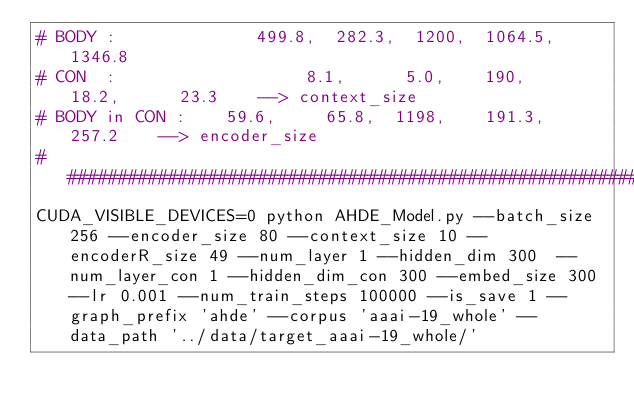<code> <loc_0><loc_0><loc_500><loc_500><_Bash_># BODY :              499.8,  282.3,  1200,  1064.5,  1346.8
# CON  :                   8.1,      5.0,    190,      18.2,      23.3    --> context_size
# BODY in CON :    59.6,     65.8,  1198,    191.3,    257.2    --> encoder_size
################################################################################
CUDA_VISIBLE_DEVICES=0 python AHDE_Model.py --batch_size 256 --encoder_size 80 --context_size 10 --encoderR_size 49 --num_layer 1 --hidden_dim 300  --num_layer_con 1 --hidden_dim_con 300 --embed_size 300 --lr 0.001 --num_train_steps 100000 --is_save 1 --graph_prefix 'ahde' --corpus 'aaai-19_whole' --data_path '../data/target_aaai-19_whole/'
</code> 